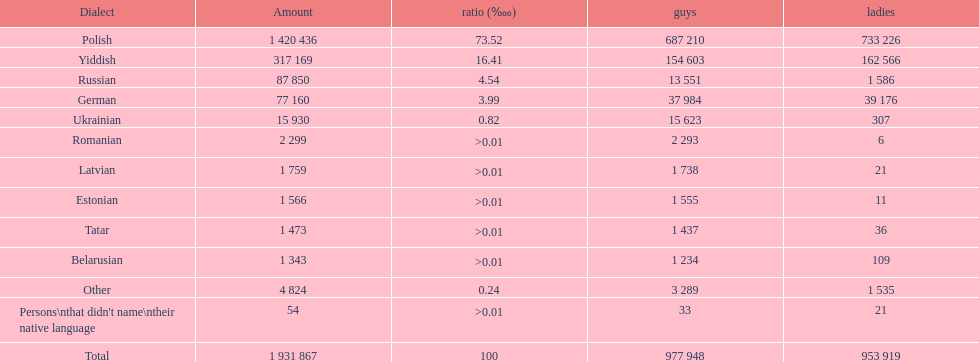The least amount of females Romanian. 